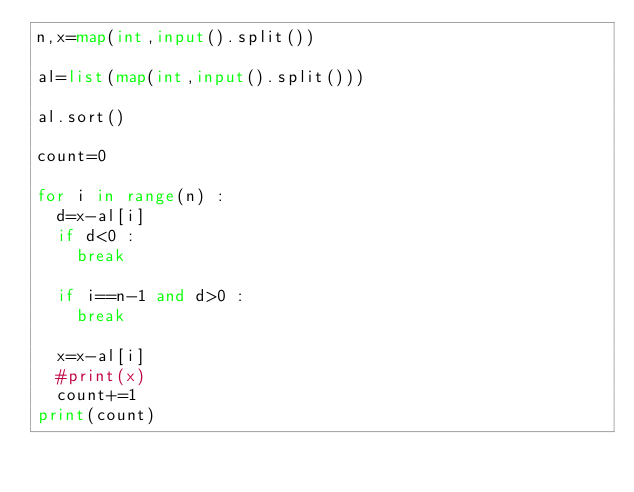Convert code to text. <code><loc_0><loc_0><loc_500><loc_500><_Python_>n,x=map(int,input().split())

al=list(map(int,input().split()))

al.sort()

count=0

for i in range(n) :
  d=x-al[i]
  if d<0 :
    break
  
  if i==n-1 and d>0 :
    break
  
  x=x-al[i]
  #print(x)
  count+=1
print(count)</code> 